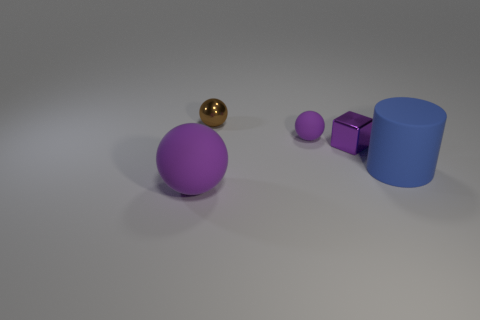Add 4 large blue rubber cylinders. How many objects exist? 9 Add 4 large blue matte cylinders. How many large blue matte cylinders are left? 5 Add 2 tiny metal spheres. How many tiny metal spheres exist? 3 Subtract all brown spheres. How many spheres are left? 2 Subtract all small spheres. How many spheres are left? 1 Subtract 0 yellow balls. How many objects are left? 5 Subtract all spheres. How many objects are left? 2 Subtract 2 balls. How many balls are left? 1 Subtract all cyan blocks. Subtract all green spheres. How many blocks are left? 1 Subtract all blue cubes. How many cyan cylinders are left? 0 